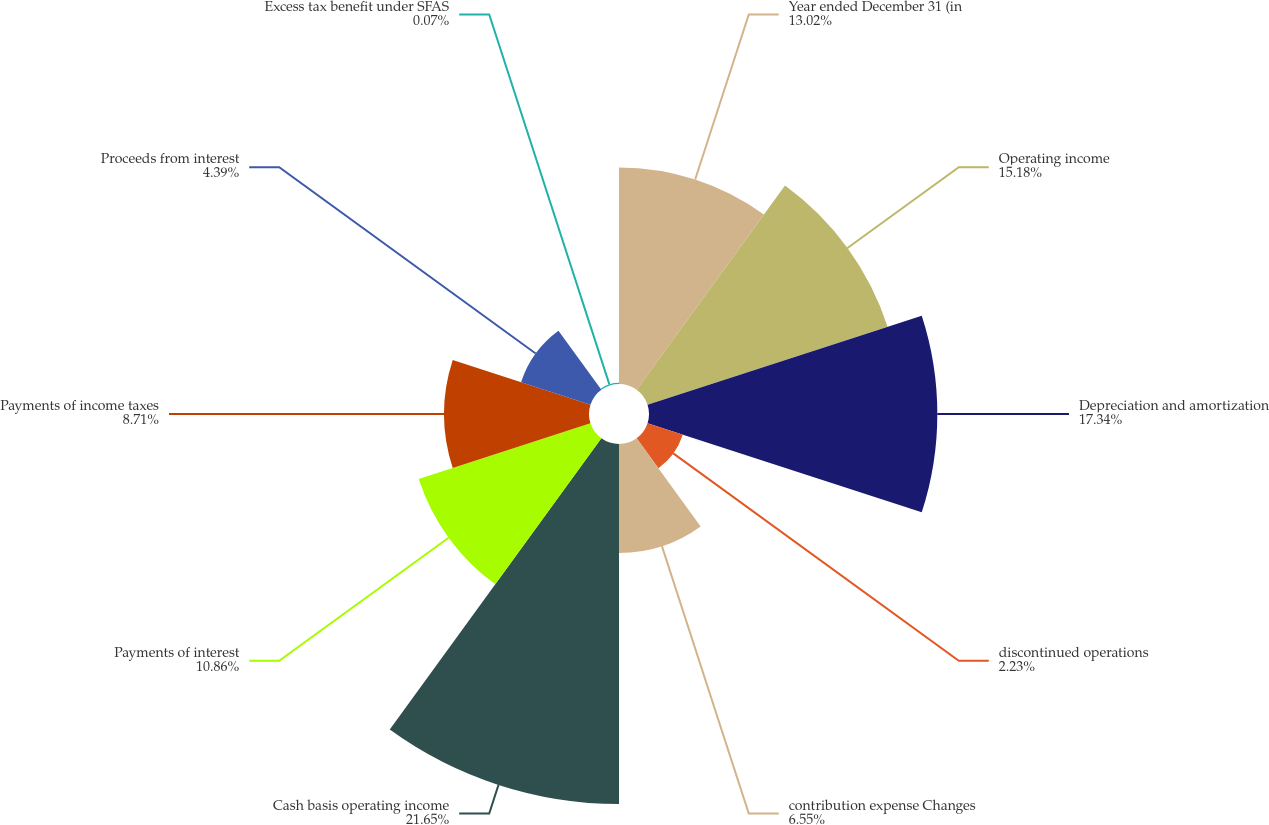Convert chart to OTSL. <chart><loc_0><loc_0><loc_500><loc_500><pie_chart><fcel>Year ended December 31 (in<fcel>Operating income<fcel>Depreciation and amortization<fcel>discontinued operations<fcel>contribution expense Changes<fcel>Cash basis operating income<fcel>Payments of interest<fcel>Payments of income taxes<fcel>Proceeds from interest<fcel>Excess tax benefit under SFAS<nl><fcel>13.02%<fcel>15.18%<fcel>17.34%<fcel>2.23%<fcel>6.55%<fcel>21.65%<fcel>10.86%<fcel>8.71%<fcel>4.39%<fcel>0.07%<nl></chart> 